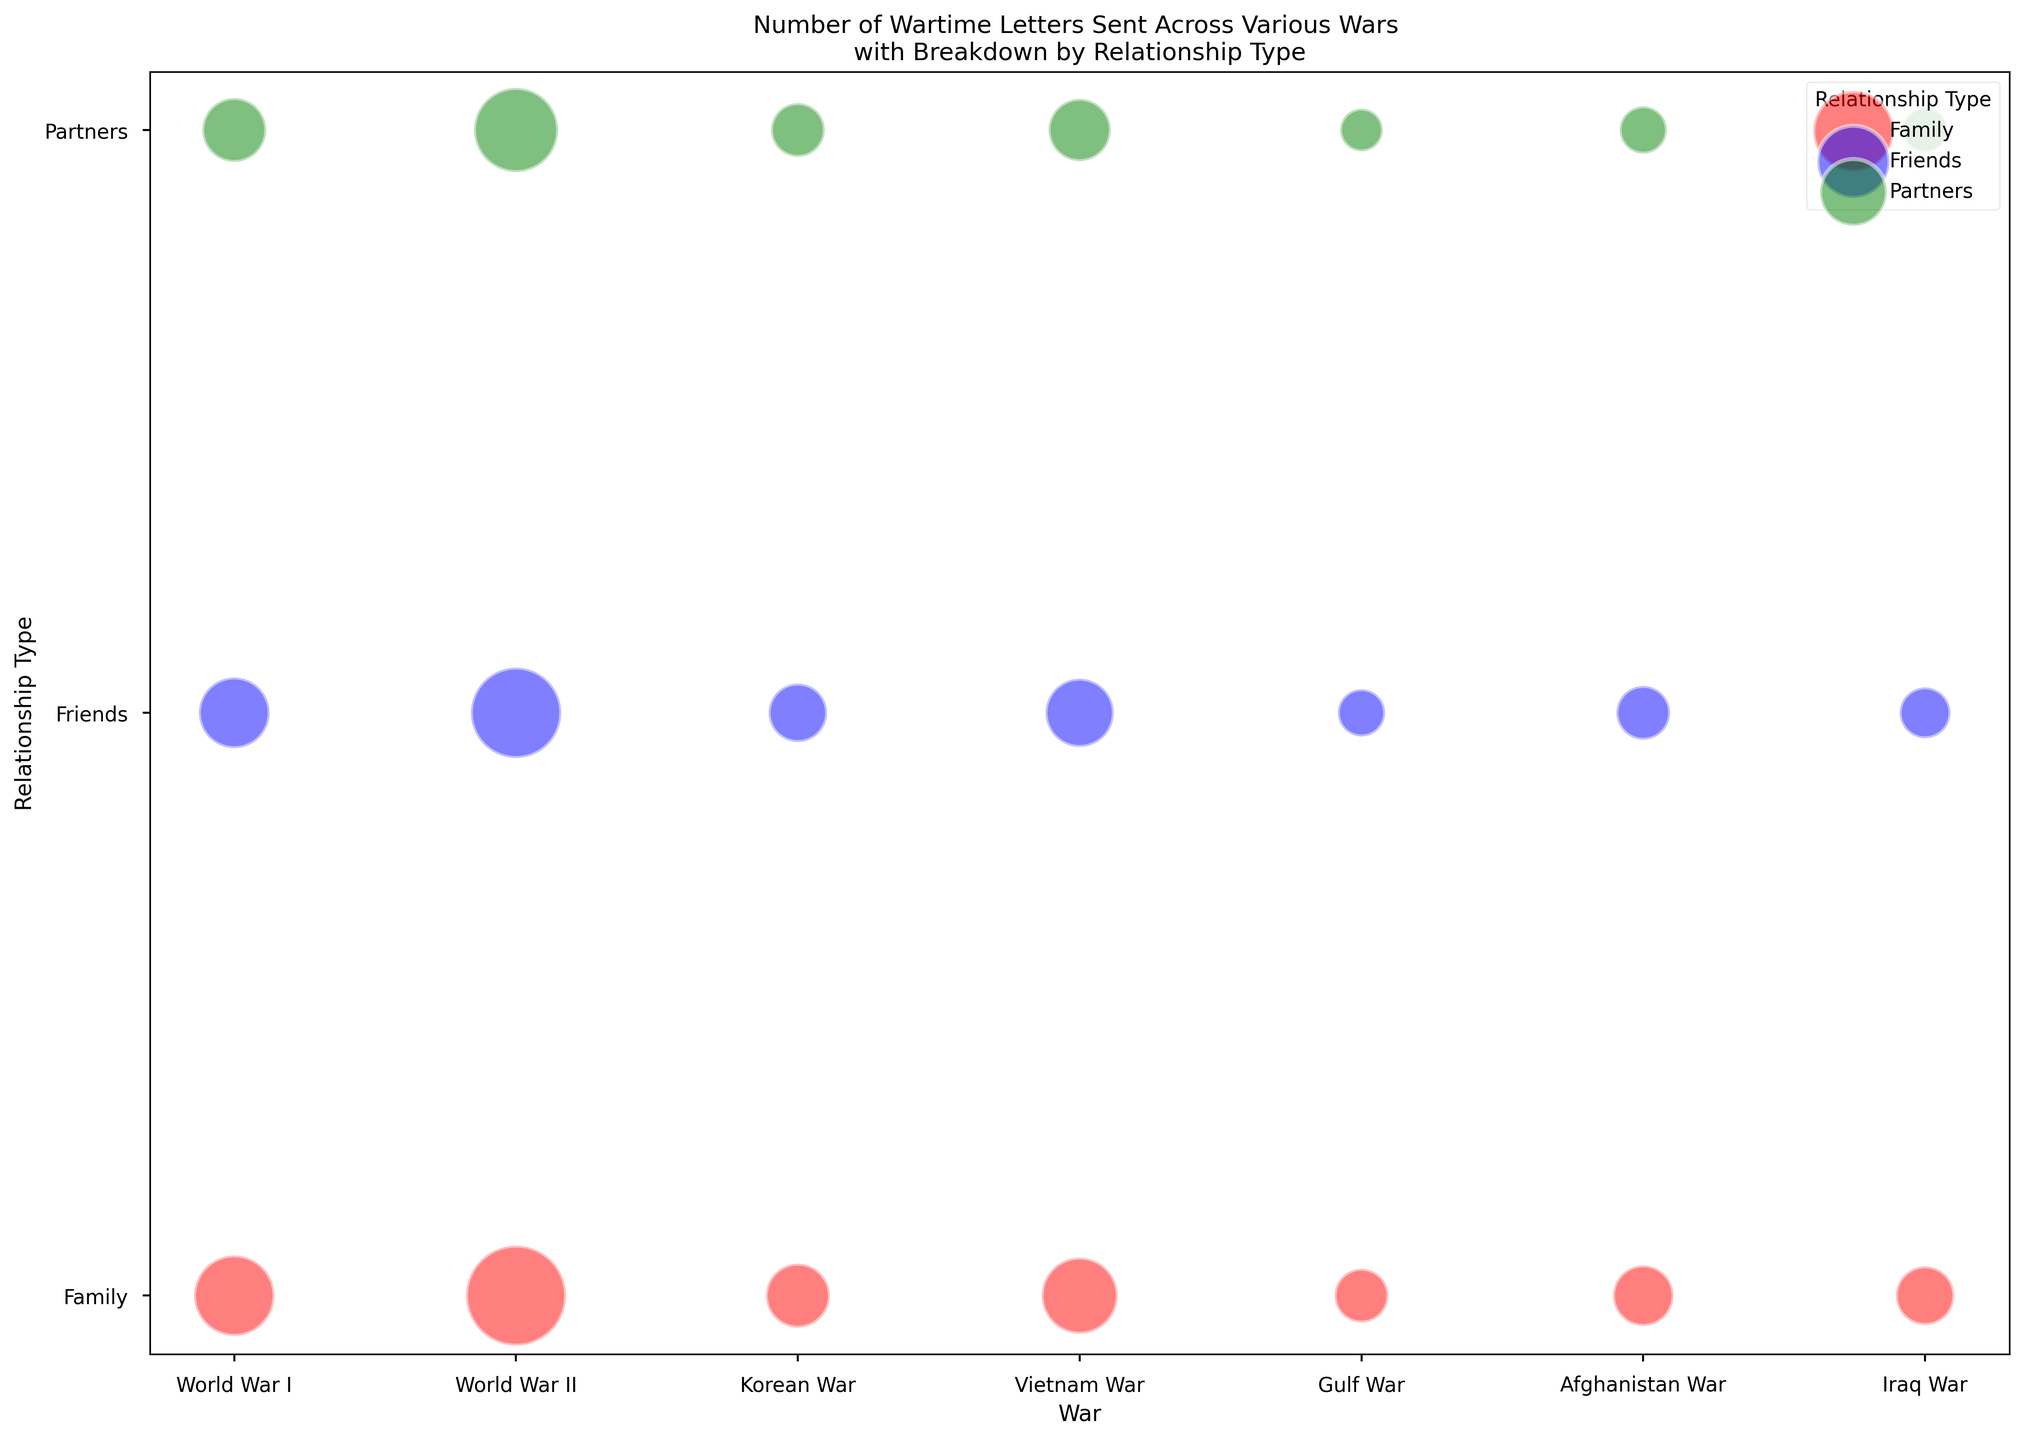What's the total number of letters sent during World War II? Add the numbers for Family, Friends, and Partners for World War II: 60,000 (Family) + 40,000 (Friends) + 30,000 (Partners).
Answer: 130,000 Which war has the highest number of letters sent to friends? Compare the sizes of the bubbles representing letters sent to Friends across all wars. The largest bubble is for World War II.
Answer: World War II How does the number of letters sent to partners during the Korean War compare to those sent during the Vietnam War? Look at the sizes of the bubbles for Partners for the Korean War and the Vietnam War. Korean War: 5,000; Vietnam War: 9,000. 9,000 is larger than 5,000.
Answer: Vietnam War has more Which relationship type consistently appears with the largest bubbles across the wars? Identify the relationship type that has the largest bubble or most frequent largest bubble across multiple wars. Family letters have the biggest bubbles (most frequent) across all wars.
Answer: Family What's the sum of letters sent to Family from the Afghanistan War and the Vietnam War? Add the numbers for Family letters from both wars: 8,000 (Afghanistan War) + 20,000 (Vietnam War).
Answer: 28,000 During which war were the number of letters to Family closest to the number of letters to Friends? Compare the size of the bubbles for Family and Friends for each war and identify the war where their sizes are the most similar. The Korean War shows sizes of 10,000 (Family) and 7,000 (Friends), which are relatively close.
Answer: Korean War Which war had the smallest number of letters sent overall? Sum the number of letters for Family, Friends, and Partners for each war, and identify the war with the smallest total sum. Gulf War has 5,000 (Family) + 3,000 (Friends) + 2,000 (Partners) = 10,000.
Answer: Gulf War How many fewer letters were sent to Partners during the Iraq War compared to the Vietnam War? Subtract the number of letters sent to Partners during the Iraq War from those sent during the Vietnam War: 9,000 (Vietnam) -2,500 (Iraq).
Answer: 6,500 What's the difference in the number of letters sent to Friends between World War I and World War II? Subtract the number of letters sent to Friends during World War I from those sent during World War II: 40,000 (WWII) -15,000 (WWI).
Answer: 25,000 Is there any war where more letters were sent to Friends than to Family? Compare the sizes of the bubbles for Family and Friends for each war. No wars have more letters sent to Friends than to Family (Family always has larger bubbles).
Answer: No 